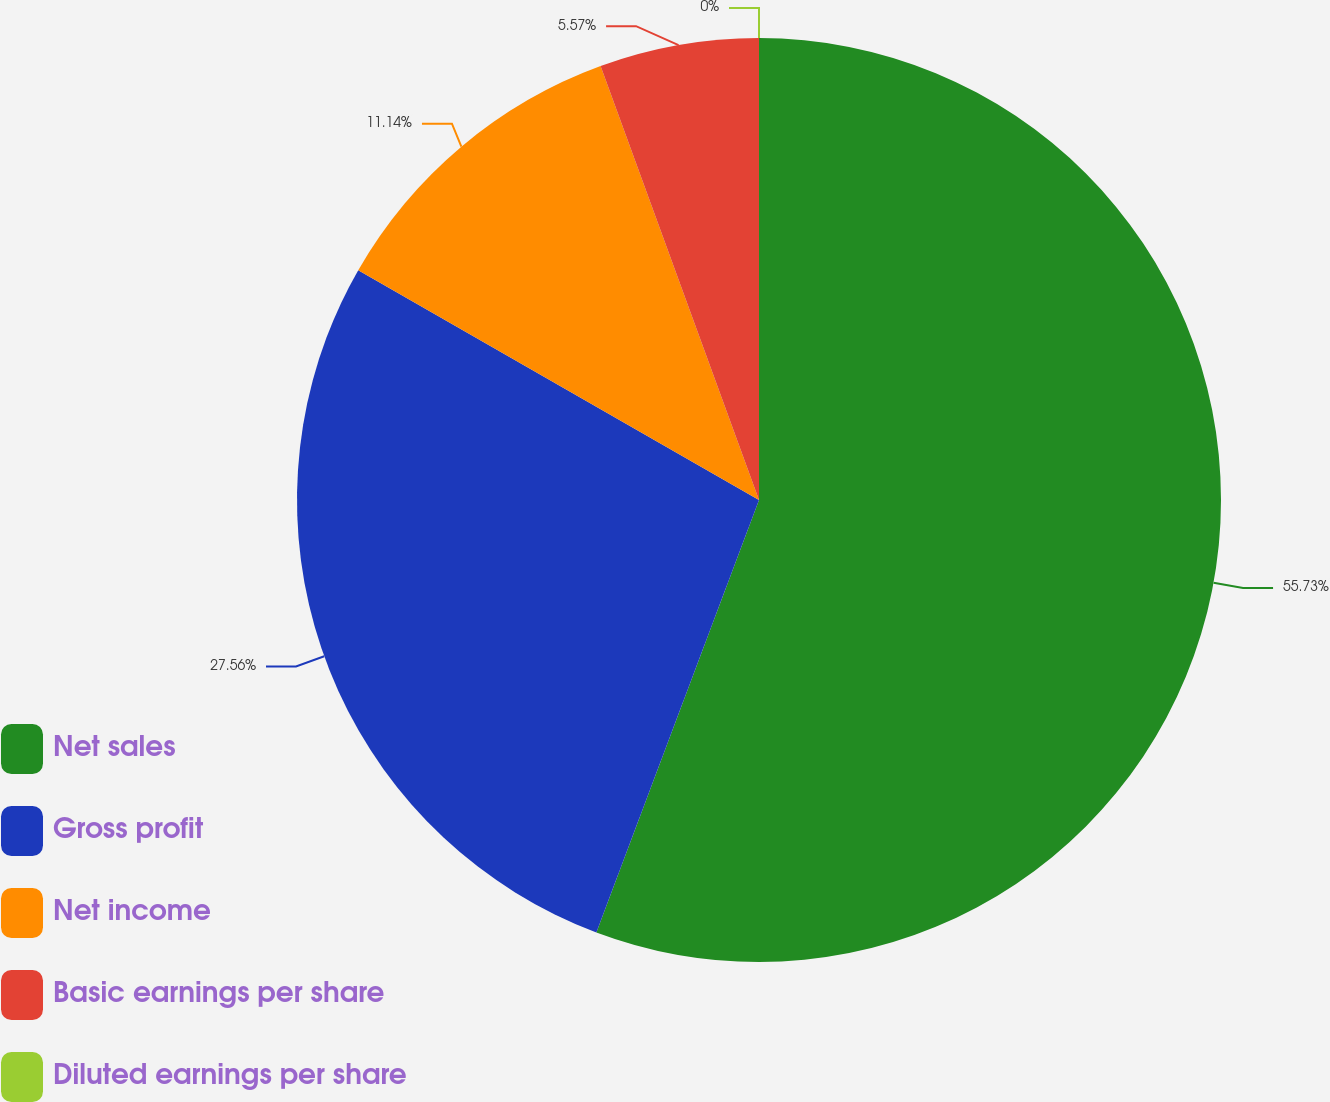Convert chart. <chart><loc_0><loc_0><loc_500><loc_500><pie_chart><fcel>Net sales<fcel>Gross profit<fcel>Net income<fcel>Basic earnings per share<fcel>Diluted earnings per share<nl><fcel>55.72%<fcel>27.56%<fcel>11.14%<fcel>5.57%<fcel>0.0%<nl></chart> 